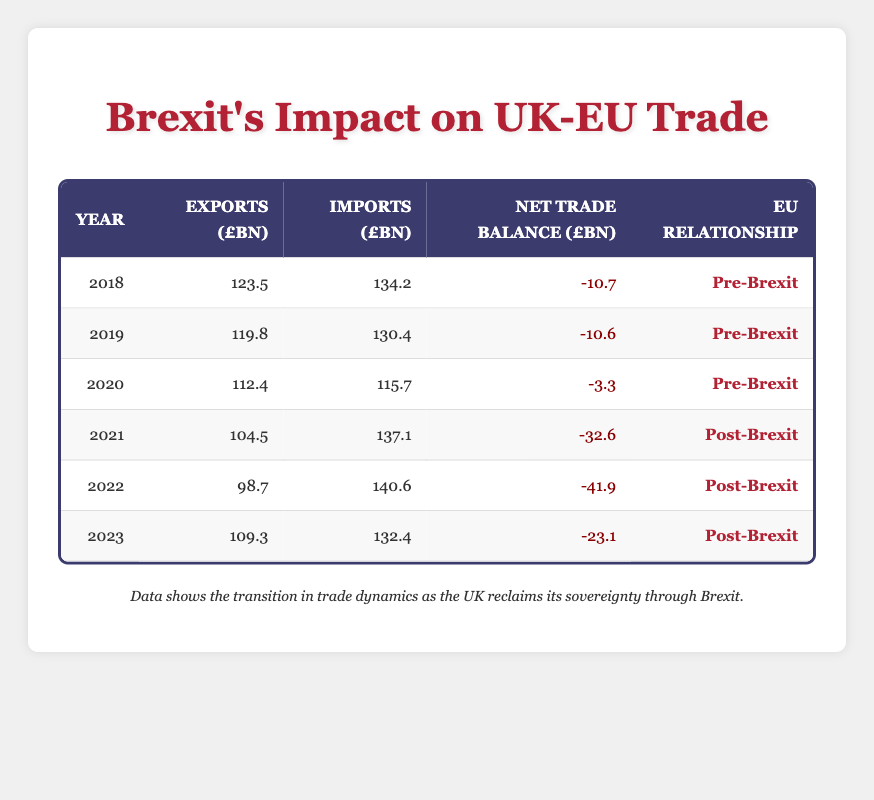What was the export level in 2018? The export level for the year 2018 is directly found in the table under the exports column for that year, which shows 123.5 billion pounds.
Answer: 123.5 billion pounds What is the net trade balance for the year 2022? Looking at the net trade balance column for the year 2022, it shows a value of -41.9 billion pounds.
Answer: -41.9 billion pounds Did the import levels increase from 2018 to 2023? By comparing the import levels for 2018 (134.2 billion pounds) and 2023 (132.4 billion pounds), we can see that the import level decreased slightly from 2018 to 2023.
Answer: No What is the total export level from 2021 to 2023? The export levels for 2021 (104.5), 2022 (98.7), and 2023 (109.3) need to be summed: 104.5 + 98.7 + 109.3 = 312.5 billion pounds.
Answer: 312.5 billion pounds Was the net trade balance positive in any year listed? All the net trade balance values for the years listed are negative, indicating that there was no year with a positive net trade balance.
Answer: No What year had the largest negative net trade balance? Reviewing the net trade balance column, the largest negative value is -41.9 billion pounds for the year 2022.
Answer: 2022 What is the average import level across all the years from 2018 to 2023? The import levels for every year are: 134.2 (2018), 130.4 (2019), 115.7 (2020), 137.1 (2021), 140.6 (2022), and 132.4 (2023). Their sum is 134.2 + 130.4 + 115.7 + 137.1 + 140.6 + 132.4 = 840.4 billion pounds. Dividing this by 6 gives an average of about 140.07 billion pounds.
Answer: 140.07 billion pounds Which year had the highest exports and what was the value? The export values for all years are: 123.5 (2018), 119.8 (2019), 112.4 (2020), 104.5 (2021), 98.7 (2022), and 109.3 (2023). The highest value is 123.5 billion pounds in 2018.
Answer: 2018, 123.5 billion pounds Did the exports decrease continuously from 2018 to 2022? From the exported values, if we compare 2018 (123.5), 2019 (119.8), 2020 (112.4), 2021 (104.5), and 2022 (98.7), we observe that exports decreased each year until 2022, but there was a slight increase in 2023 (109.3). Thus, they did not decrease continuously.
Answer: No 